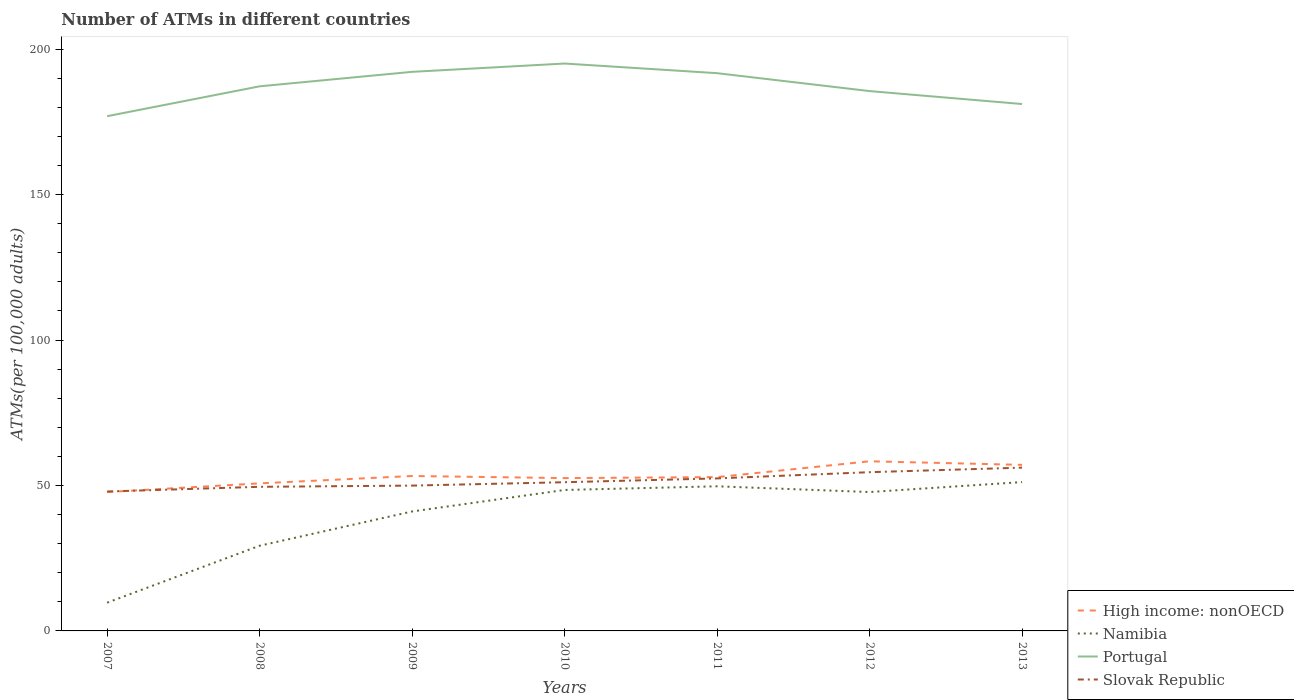How many different coloured lines are there?
Provide a succinct answer. 4. Does the line corresponding to Namibia intersect with the line corresponding to Portugal?
Your answer should be compact. No. Is the number of lines equal to the number of legend labels?
Your answer should be compact. Yes. Across all years, what is the maximum number of ATMs in Slovak Republic?
Give a very brief answer. 47.92. In which year was the number of ATMs in Namibia maximum?
Give a very brief answer. 2007. What is the total number of ATMs in Slovak Republic in the graph?
Offer a terse response. -2.89. What is the difference between the highest and the second highest number of ATMs in Namibia?
Offer a terse response. 41.45. How many years are there in the graph?
Give a very brief answer. 7. Does the graph contain grids?
Give a very brief answer. No. How are the legend labels stacked?
Provide a short and direct response. Vertical. What is the title of the graph?
Your response must be concise. Number of ATMs in different countries. Does "Ukraine" appear as one of the legend labels in the graph?
Give a very brief answer. No. What is the label or title of the X-axis?
Make the answer very short. Years. What is the label or title of the Y-axis?
Your answer should be very brief. ATMs(per 100,0 adults). What is the ATMs(per 100,000 adults) in High income: nonOECD in 2007?
Your answer should be compact. 47.74. What is the ATMs(per 100,000 adults) in Namibia in 2007?
Keep it short and to the point. 9.71. What is the ATMs(per 100,000 adults) of Portugal in 2007?
Your answer should be very brief. 176.94. What is the ATMs(per 100,000 adults) in Slovak Republic in 2007?
Provide a succinct answer. 47.92. What is the ATMs(per 100,000 adults) of High income: nonOECD in 2008?
Give a very brief answer. 50.72. What is the ATMs(per 100,000 adults) in Namibia in 2008?
Your response must be concise. 29.28. What is the ATMs(per 100,000 adults) in Portugal in 2008?
Offer a terse response. 187.21. What is the ATMs(per 100,000 adults) of Slovak Republic in 2008?
Your answer should be very brief. 49.54. What is the ATMs(per 100,000 adults) of High income: nonOECD in 2009?
Give a very brief answer. 53.26. What is the ATMs(per 100,000 adults) in Namibia in 2009?
Provide a succinct answer. 41.06. What is the ATMs(per 100,000 adults) in Portugal in 2009?
Make the answer very short. 192.19. What is the ATMs(per 100,000 adults) in Slovak Republic in 2009?
Offer a terse response. 49.96. What is the ATMs(per 100,000 adults) of High income: nonOECD in 2010?
Provide a succinct answer. 52.53. What is the ATMs(per 100,000 adults) of Namibia in 2010?
Provide a short and direct response. 48.46. What is the ATMs(per 100,000 adults) in Portugal in 2010?
Your response must be concise. 195.04. What is the ATMs(per 100,000 adults) of Slovak Republic in 2010?
Provide a short and direct response. 51.12. What is the ATMs(per 100,000 adults) in High income: nonOECD in 2011?
Your answer should be compact. 52.87. What is the ATMs(per 100,000 adults) of Namibia in 2011?
Keep it short and to the point. 49.72. What is the ATMs(per 100,000 adults) in Portugal in 2011?
Keep it short and to the point. 191.73. What is the ATMs(per 100,000 adults) in Slovak Republic in 2011?
Give a very brief answer. 52.43. What is the ATMs(per 100,000 adults) of High income: nonOECD in 2012?
Give a very brief answer. 58.31. What is the ATMs(per 100,000 adults) of Namibia in 2012?
Give a very brief answer. 47.74. What is the ATMs(per 100,000 adults) in Portugal in 2012?
Give a very brief answer. 185.57. What is the ATMs(per 100,000 adults) of Slovak Republic in 2012?
Ensure brevity in your answer.  54.57. What is the ATMs(per 100,000 adults) in High income: nonOECD in 2013?
Provide a short and direct response. 57.08. What is the ATMs(per 100,000 adults) of Namibia in 2013?
Offer a terse response. 51.16. What is the ATMs(per 100,000 adults) in Portugal in 2013?
Provide a succinct answer. 181.12. What is the ATMs(per 100,000 adults) in Slovak Republic in 2013?
Ensure brevity in your answer.  56.13. Across all years, what is the maximum ATMs(per 100,000 adults) of High income: nonOECD?
Offer a very short reply. 58.31. Across all years, what is the maximum ATMs(per 100,000 adults) of Namibia?
Offer a very short reply. 51.16. Across all years, what is the maximum ATMs(per 100,000 adults) in Portugal?
Ensure brevity in your answer.  195.04. Across all years, what is the maximum ATMs(per 100,000 adults) in Slovak Republic?
Make the answer very short. 56.13. Across all years, what is the minimum ATMs(per 100,000 adults) of High income: nonOECD?
Offer a very short reply. 47.74. Across all years, what is the minimum ATMs(per 100,000 adults) in Namibia?
Ensure brevity in your answer.  9.71. Across all years, what is the minimum ATMs(per 100,000 adults) of Portugal?
Give a very brief answer. 176.94. Across all years, what is the minimum ATMs(per 100,000 adults) of Slovak Republic?
Keep it short and to the point. 47.92. What is the total ATMs(per 100,000 adults) of High income: nonOECD in the graph?
Your answer should be very brief. 372.52. What is the total ATMs(per 100,000 adults) in Namibia in the graph?
Your response must be concise. 277.13. What is the total ATMs(per 100,000 adults) in Portugal in the graph?
Your answer should be compact. 1309.81. What is the total ATMs(per 100,000 adults) of Slovak Republic in the graph?
Keep it short and to the point. 361.66. What is the difference between the ATMs(per 100,000 adults) of High income: nonOECD in 2007 and that in 2008?
Offer a terse response. -2.98. What is the difference between the ATMs(per 100,000 adults) of Namibia in 2007 and that in 2008?
Give a very brief answer. -19.57. What is the difference between the ATMs(per 100,000 adults) in Portugal in 2007 and that in 2008?
Your response must be concise. -10.27. What is the difference between the ATMs(per 100,000 adults) in Slovak Republic in 2007 and that in 2008?
Your answer should be compact. -1.62. What is the difference between the ATMs(per 100,000 adults) in High income: nonOECD in 2007 and that in 2009?
Keep it short and to the point. -5.52. What is the difference between the ATMs(per 100,000 adults) in Namibia in 2007 and that in 2009?
Offer a terse response. -31.35. What is the difference between the ATMs(per 100,000 adults) of Portugal in 2007 and that in 2009?
Make the answer very short. -15.24. What is the difference between the ATMs(per 100,000 adults) of Slovak Republic in 2007 and that in 2009?
Ensure brevity in your answer.  -2.04. What is the difference between the ATMs(per 100,000 adults) of High income: nonOECD in 2007 and that in 2010?
Your response must be concise. -4.8. What is the difference between the ATMs(per 100,000 adults) of Namibia in 2007 and that in 2010?
Your answer should be compact. -38.74. What is the difference between the ATMs(per 100,000 adults) in Portugal in 2007 and that in 2010?
Make the answer very short. -18.1. What is the difference between the ATMs(per 100,000 adults) of Slovak Republic in 2007 and that in 2010?
Offer a terse response. -3.19. What is the difference between the ATMs(per 100,000 adults) in High income: nonOECD in 2007 and that in 2011?
Give a very brief answer. -5.14. What is the difference between the ATMs(per 100,000 adults) in Namibia in 2007 and that in 2011?
Offer a terse response. -40. What is the difference between the ATMs(per 100,000 adults) of Portugal in 2007 and that in 2011?
Offer a terse response. -14.79. What is the difference between the ATMs(per 100,000 adults) in Slovak Republic in 2007 and that in 2011?
Make the answer very short. -4.51. What is the difference between the ATMs(per 100,000 adults) of High income: nonOECD in 2007 and that in 2012?
Your response must be concise. -10.57. What is the difference between the ATMs(per 100,000 adults) in Namibia in 2007 and that in 2012?
Your response must be concise. -38.03. What is the difference between the ATMs(per 100,000 adults) of Portugal in 2007 and that in 2012?
Your answer should be compact. -8.63. What is the difference between the ATMs(per 100,000 adults) in Slovak Republic in 2007 and that in 2012?
Offer a terse response. -6.64. What is the difference between the ATMs(per 100,000 adults) in High income: nonOECD in 2007 and that in 2013?
Ensure brevity in your answer.  -9.34. What is the difference between the ATMs(per 100,000 adults) in Namibia in 2007 and that in 2013?
Give a very brief answer. -41.45. What is the difference between the ATMs(per 100,000 adults) of Portugal in 2007 and that in 2013?
Make the answer very short. -4.18. What is the difference between the ATMs(per 100,000 adults) in Slovak Republic in 2007 and that in 2013?
Provide a short and direct response. -8.21. What is the difference between the ATMs(per 100,000 adults) of High income: nonOECD in 2008 and that in 2009?
Your answer should be very brief. -2.53. What is the difference between the ATMs(per 100,000 adults) of Namibia in 2008 and that in 2009?
Keep it short and to the point. -11.78. What is the difference between the ATMs(per 100,000 adults) of Portugal in 2008 and that in 2009?
Offer a very short reply. -4.98. What is the difference between the ATMs(per 100,000 adults) in Slovak Republic in 2008 and that in 2009?
Your answer should be compact. -0.42. What is the difference between the ATMs(per 100,000 adults) in High income: nonOECD in 2008 and that in 2010?
Give a very brief answer. -1.81. What is the difference between the ATMs(per 100,000 adults) in Namibia in 2008 and that in 2010?
Your answer should be compact. -19.17. What is the difference between the ATMs(per 100,000 adults) of Portugal in 2008 and that in 2010?
Ensure brevity in your answer.  -7.83. What is the difference between the ATMs(per 100,000 adults) of Slovak Republic in 2008 and that in 2010?
Provide a succinct answer. -1.58. What is the difference between the ATMs(per 100,000 adults) of High income: nonOECD in 2008 and that in 2011?
Keep it short and to the point. -2.15. What is the difference between the ATMs(per 100,000 adults) in Namibia in 2008 and that in 2011?
Keep it short and to the point. -20.43. What is the difference between the ATMs(per 100,000 adults) in Portugal in 2008 and that in 2011?
Ensure brevity in your answer.  -4.52. What is the difference between the ATMs(per 100,000 adults) of Slovak Republic in 2008 and that in 2011?
Provide a succinct answer. -2.89. What is the difference between the ATMs(per 100,000 adults) of High income: nonOECD in 2008 and that in 2012?
Your answer should be very brief. -7.59. What is the difference between the ATMs(per 100,000 adults) of Namibia in 2008 and that in 2012?
Offer a terse response. -18.46. What is the difference between the ATMs(per 100,000 adults) in Portugal in 2008 and that in 2012?
Provide a short and direct response. 1.64. What is the difference between the ATMs(per 100,000 adults) of Slovak Republic in 2008 and that in 2012?
Make the answer very short. -5.03. What is the difference between the ATMs(per 100,000 adults) of High income: nonOECD in 2008 and that in 2013?
Your answer should be very brief. -6.36. What is the difference between the ATMs(per 100,000 adults) in Namibia in 2008 and that in 2013?
Keep it short and to the point. -21.88. What is the difference between the ATMs(per 100,000 adults) in Portugal in 2008 and that in 2013?
Offer a very short reply. 6.09. What is the difference between the ATMs(per 100,000 adults) of Slovak Republic in 2008 and that in 2013?
Offer a very short reply. -6.59. What is the difference between the ATMs(per 100,000 adults) of High income: nonOECD in 2009 and that in 2010?
Offer a very short reply. 0.72. What is the difference between the ATMs(per 100,000 adults) in Namibia in 2009 and that in 2010?
Keep it short and to the point. -7.39. What is the difference between the ATMs(per 100,000 adults) in Portugal in 2009 and that in 2010?
Offer a terse response. -2.86. What is the difference between the ATMs(per 100,000 adults) of Slovak Republic in 2009 and that in 2010?
Your response must be concise. -1.16. What is the difference between the ATMs(per 100,000 adults) in High income: nonOECD in 2009 and that in 2011?
Provide a succinct answer. 0.38. What is the difference between the ATMs(per 100,000 adults) in Namibia in 2009 and that in 2011?
Give a very brief answer. -8.65. What is the difference between the ATMs(per 100,000 adults) in Portugal in 2009 and that in 2011?
Make the answer very short. 0.46. What is the difference between the ATMs(per 100,000 adults) in Slovak Republic in 2009 and that in 2011?
Ensure brevity in your answer.  -2.47. What is the difference between the ATMs(per 100,000 adults) of High income: nonOECD in 2009 and that in 2012?
Offer a very short reply. -5.05. What is the difference between the ATMs(per 100,000 adults) in Namibia in 2009 and that in 2012?
Keep it short and to the point. -6.68. What is the difference between the ATMs(per 100,000 adults) of Portugal in 2009 and that in 2012?
Your response must be concise. 6.62. What is the difference between the ATMs(per 100,000 adults) of Slovak Republic in 2009 and that in 2012?
Provide a succinct answer. -4.61. What is the difference between the ATMs(per 100,000 adults) in High income: nonOECD in 2009 and that in 2013?
Offer a very short reply. -3.83. What is the difference between the ATMs(per 100,000 adults) of Namibia in 2009 and that in 2013?
Provide a succinct answer. -10.1. What is the difference between the ATMs(per 100,000 adults) in Portugal in 2009 and that in 2013?
Provide a succinct answer. 11.06. What is the difference between the ATMs(per 100,000 adults) of Slovak Republic in 2009 and that in 2013?
Offer a very short reply. -6.17. What is the difference between the ATMs(per 100,000 adults) of High income: nonOECD in 2010 and that in 2011?
Your answer should be compact. -0.34. What is the difference between the ATMs(per 100,000 adults) in Namibia in 2010 and that in 2011?
Offer a very short reply. -1.26. What is the difference between the ATMs(per 100,000 adults) in Portugal in 2010 and that in 2011?
Give a very brief answer. 3.31. What is the difference between the ATMs(per 100,000 adults) in Slovak Republic in 2010 and that in 2011?
Your answer should be compact. -1.31. What is the difference between the ATMs(per 100,000 adults) in High income: nonOECD in 2010 and that in 2012?
Your answer should be compact. -5.78. What is the difference between the ATMs(per 100,000 adults) of Namibia in 2010 and that in 2012?
Ensure brevity in your answer.  0.72. What is the difference between the ATMs(per 100,000 adults) in Portugal in 2010 and that in 2012?
Offer a terse response. 9.47. What is the difference between the ATMs(per 100,000 adults) of Slovak Republic in 2010 and that in 2012?
Your response must be concise. -3.45. What is the difference between the ATMs(per 100,000 adults) of High income: nonOECD in 2010 and that in 2013?
Give a very brief answer. -4.55. What is the difference between the ATMs(per 100,000 adults) of Namibia in 2010 and that in 2013?
Your answer should be compact. -2.7. What is the difference between the ATMs(per 100,000 adults) in Portugal in 2010 and that in 2013?
Provide a short and direct response. 13.92. What is the difference between the ATMs(per 100,000 adults) in Slovak Republic in 2010 and that in 2013?
Provide a short and direct response. -5.01. What is the difference between the ATMs(per 100,000 adults) in High income: nonOECD in 2011 and that in 2012?
Keep it short and to the point. -5.44. What is the difference between the ATMs(per 100,000 adults) in Namibia in 2011 and that in 2012?
Your answer should be very brief. 1.97. What is the difference between the ATMs(per 100,000 adults) of Portugal in 2011 and that in 2012?
Offer a terse response. 6.16. What is the difference between the ATMs(per 100,000 adults) of Slovak Republic in 2011 and that in 2012?
Give a very brief answer. -2.14. What is the difference between the ATMs(per 100,000 adults) in High income: nonOECD in 2011 and that in 2013?
Provide a short and direct response. -4.21. What is the difference between the ATMs(per 100,000 adults) in Namibia in 2011 and that in 2013?
Your answer should be compact. -1.44. What is the difference between the ATMs(per 100,000 adults) in Portugal in 2011 and that in 2013?
Offer a very short reply. 10.6. What is the difference between the ATMs(per 100,000 adults) of Slovak Republic in 2011 and that in 2013?
Offer a very short reply. -3.7. What is the difference between the ATMs(per 100,000 adults) of High income: nonOECD in 2012 and that in 2013?
Your answer should be very brief. 1.23. What is the difference between the ATMs(per 100,000 adults) in Namibia in 2012 and that in 2013?
Give a very brief answer. -3.42. What is the difference between the ATMs(per 100,000 adults) in Portugal in 2012 and that in 2013?
Offer a very short reply. 4.45. What is the difference between the ATMs(per 100,000 adults) in Slovak Republic in 2012 and that in 2013?
Give a very brief answer. -1.56. What is the difference between the ATMs(per 100,000 adults) of High income: nonOECD in 2007 and the ATMs(per 100,000 adults) of Namibia in 2008?
Keep it short and to the point. 18.46. What is the difference between the ATMs(per 100,000 adults) of High income: nonOECD in 2007 and the ATMs(per 100,000 adults) of Portugal in 2008?
Give a very brief answer. -139.47. What is the difference between the ATMs(per 100,000 adults) in High income: nonOECD in 2007 and the ATMs(per 100,000 adults) in Slovak Republic in 2008?
Provide a succinct answer. -1.8. What is the difference between the ATMs(per 100,000 adults) in Namibia in 2007 and the ATMs(per 100,000 adults) in Portugal in 2008?
Offer a terse response. -177.5. What is the difference between the ATMs(per 100,000 adults) in Namibia in 2007 and the ATMs(per 100,000 adults) in Slovak Republic in 2008?
Offer a very short reply. -39.83. What is the difference between the ATMs(per 100,000 adults) in Portugal in 2007 and the ATMs(per 100,000 adults) in Slovak Republic in 2008?
Make the answer very short. 127.4. What is the difference between the ATMs(per 100,000 adults) in High income: nonOECD in 2007 and the ATMs(per 100,000 adults) in Namibia in 2009?
Your answer should be compact. 6.68. What is the difference between the ATMs(per 100,000 adults) of High income: nonOECD in 2007 and the ATMs(per 100,000 adults) of Portugal in 2009?
Offer a very short reply. -144.45. What is the difference between the ATMs(per 100,000 adults) of High income: nonOECD in 2007 and the ATMs(per 100,000 adults) of Slovak Republic in 2009?
Your answer should be compact. -2.22. What is the difference between the ATMs(per 100,000 adults) of Namibia in 2007 and the ATMs(per 100,000 adults) of Portugal in 2009?
Provide a succinct answer. -182.48. What is the difference between the ATMs(per 100,000 adults) of Namibia in 2007 and the ATMs(per 100,000 adults) of Slovak Republic in 2009?
Ensure brevity in your answer.  -40.25. What is the difference between the ATMs(per 100,000 adults) in Portugal in 2007 and the ATMs(per 100,000 adults) in Slovak Republic in 2009?
Your answer should be compact. 126.99. What is the difference between the ATMs(per 100,000 adults) in High income: nonOECD in 2007 and the ATMs(per 100,000 adults) in Namibia in 2010?
Offer a terse response. -0.72. What is the difference between the ATMs(per 100,000 adults) in High income: nonOECD in 2007 and the ATMs(per 100,000 adults) in Portugal in 2010?
Keep it short and to the point. -147.3. What is the difference between the ATMs(per 100,000 adults) of High income: nonOECD in 2007 and the ATMs(per 100,000 adults) of Slovak Republic in 2010?
Offer a terse response. -3.38. What is the difference between the ATMs(per 100,000 adults) of Namibia in 2007 and the ATMs(per 100,000 adults) of Portugal in 2010?
Provide a short and direct response. -185.33. What is the difference between the ATMs(per 100,000 adults) of Namibia in 2007 and the ATMs(per 100,000 adults) of Slovak Republic in 2010?
Your answer should be very brief. -41.4. What is the difference between the ATMs(per 100,000 adults) of Portugal in 2007 and the ATMs(per 100,000 adults) of Slovak Republic in 2010?
Make the answer very short. 125.83. What is the difference between the ATMs(per 100,000 adults) in High income: nonOECD in 2007 and the ATMs(per 100,000 adults) in Namibia in 2011?
Give a very brief answer. -1.98. What is the difference between the ATMs(per 100,000 adults) of High income: nonOECD in 2007 and the ATMs(per 100,000 adults) of Portugal in 2011?
Make the answer very short. -143.99. What is the difference between the ATMs(per 100,000 adults) in High income: nonOECD in 2007 and the ATMs(per 100,000 adults) in Slovak Republic in 2011?
Ensure brevity in your answer.  -4.69. What is the difference between the ATMs(per 100,000 adults) of Namibia in 2007 and the ATMs(per 100,000 adults) of Portugal in 2011?
Your response must be concise. -182.02. What is the difference between the ATMs(per 100,000 adults) of Namibia in 2007 and the ATMs(per 100,000 adults) of Slovak Republic in 2011?
Offer a terse response. -42.72. What is the difference between the ATMs(per 100,000 adults) of Portugal in 2007 and the ATMs(per 100,000 adults) of Slovak Republic in 2011?
Your answer should be compact. 124.51. What is the difference between the ATMs(per 100,000 adults) in High income: nonOECD in 2007 and the ATMs(per 100,000 adults) in Namibia in 2012?
Offer a very short reply. -0. What is the difference between the ATMs(per 100,000 adults) of High income: nonOECD in 2007 and the ATMs(per 100,000 adults) of Portugal in 2012?
Provide a succinct answer. -137.83. What is the difference between the ATMs(per 100,000 adults) in High income: nonOECD in 2007 and the ATMs(per 100,000 adults) in Slovak Republic in 2012?
Offer a very short reply. -6.83. What is the difference between the ATMs(per 100,000 adults) in Namibia in 2007 and the ATMs(per 100,000 adults) in Portugal in 2012?
Your response must be concise. -175.86. What is the difference between the ATMs(per 100,000 adults) in Namibia in 2007 and the ATMs(per 100,000 adults) in Slovak Republic in 2012?
Your answer should be compact. -44.85. What is the difference between the ATMs(per 100,000 adults) in Portugal in 2007 and the ATMs(per 100,000 adults) in Slovak Republic in 2012?
Give a very brief answer. 122.38. What is the difference between the ATMs(per 100,000 adults) in High income: nonOECD in 2007 and the ATMs(per 100,000 adults) in Namibia in 2013?
Provide a succinct answer. -3.42. What is the difference between the ATMs(per 100,000 adults) of High income: nonOECD in 2007 and the ATMs(per 100,000 adults) of Portugal in 2013?
Offer a very short reply. -133.39. What is the difference between the ATMs(per 100,000 adults) of High income: nonOECD in 2007 and the ATMs(per 100,000 adults) of Slovak Republic in 2013?
Your answer should be compact. -8.39. What is the difference between the ATMs(per 100,000 adults) in Namibia in 2007 and the ATMs(per 100,000 adults) in Portugal in 2013?
Your answer should be compact. -171.41. What is the difference between the ATMs(per 100,000 adults) in Namibia in 2007 and the ATMs(per 100,000 adults) in Slovak Republic in 2013?
Make the answer very short. -46.42. What is the difference between the ATMs(per 100,000 adults) of Portugal in 2007 and the ATMs(per 100,000 adults) of Slovak Republic in 2013?
Make the answer very short. 120.81. What is the difference between the ATMs(per 100,000 adults) in High income: nonOECD in 2008 and the ATMs(per 100,000 adults) in Namibia in 2009?
Offer a very short reply. 9.66. What is the difference between the ATMs(per 100,000 adults) in High income: nonOECD in 2008 and the ATMs(per 100,000 adults) in Portugal in 2009?
Ensure brevity in your answer.  -141.47. What is the difference between the ATMs(per 100,000 adults) in High income: nonOECD in 2008 and the ATMs(per 100,000 adults) in Slovak Republic in 2009?
Your response must be concise. 0.76. What is the difference between the ATMs(per 100,000 adults) of Namibia in 2008 and the ATMs(per 100,000 adults) of Portugal in 2009?
Ensure brevity in your answer.  -162.9. What is the difference between the ATMs(per 100,000 adults) in Namibia in 2008 and the ATMs(per 100,000 adults) in Slovak Republic in 2009?
Your response must be concise. -20.67. What is the difference between the ATMs(per 100,000 adults) of Portugal in 2008 and the ATMs(per 100,000 adults) of Slovak Republic in 2009?
Provide a short and direct response. 137.25. What is the difference between the ATMs(per 100,000 adults) of High income: nonOECD in 2008 and the ATMs(per 100,000 adults) of Namibia in 2010?
Keep it short and to the point. 2.27. What is the difference between the ATMs(per 100,000 adults) of High income: nonOECD in 2008 and the ATMs(per 100,000 adults) of Portugal in 2010?
Provide a short and direct response. -144.32. What is the difference between the ATMs(per 100,000 adults) of High income: nonOECD in 2008 and the ATMs(per 100,000 adults) of Slovak Republic in 2010?
Your answer should be very brief. -0.39. What is the difference between the ATMs(per 100,000 adults) of Namibia in 2008 and the ATMs(per 100,000 adults) of Portugal in 2010?
Offer a very short reply. -165.76. What is the difference between the ATMs(per 100,000 adults) of Namibia in 2008 and the ATMs(per 100,000 adults) of Slovak Republic in 2010?
Your answer should be compact. -21.83. What is the difference between the ATMs(per 100,000 adults) of Portugal in 2008 and the ATMs(per 100,000 adults) of Slovak Republic in 2010?
Give a very brief answer. 136.09. What is the difference between the ATMs(per 100,000 adults) of High income: nonOECD in 2008 and the ATMs(per 100,000 adults) of Portugal in 2011?
Your answer should be compact. -141.01. What is the difference between the ATMs(per 100,000 adults) in High income: nonOECD in 2008 and the ATMs(per 100,000 adults) in Slovak Republic in 2011?
Offer a terse response. -1.71. What is the difference between the ATMs(per 100,000 adults) in Namibia in 2008 and the ATMs(per 100,000 adults) in Portugal in 2011?
Keep it short and to the point. -162.45. What is the difference between the ATMs(per 100,000 adults) of Namibia in 2008 and the ATMs(per 100,000 adults) of Slovak Republic in 2011?
Keep it short and to the point. -23.15. What is the difference between the ATMs(per 100,000 adults) in Portugal in 2008 and the ATMs(per 100,000 adults) in Slovak Republic in 2011?
Your answer should be very brief. 134.78. What is the difference between the ATMs(per 100,000 adults) of High income: nonOECD in 2008 and the ATMs(per 100,000 adults) of Namibia in 2012?
Provide a succinct answer. 2.98. What is the difference between the ATMs(per 100,000 adults) in High income: nonOECD in 2008 and the ATMs(per 100,000 adults) in Portugal in 2012?
Your response must be concise. -134.85. What is the difference between the ATMs(per 100,000 adults) in High income: nonOECD in 2008 and the ATMs(per 100,000 adults) in Slovak Republic in 2012?
Offer a very short reply. -3.84. What is the difference between the ATMs(per 100,000 adults) in Namibia in 2008 and the ATMs(per 100,000 adults) in Portugal in 2012?
Offer a terse response. -156.29. What is the difference between the ATMs(per 100,000 adults) of Namibia in 2008 and the ATMs(per 100,000 adults) of Slovak Republic in 2012?
Make the answer very short. -25.28. What is the difference between the ATMs(per 100,000 adults) of Portugal in 2008 and the ATMs(per 100,000 adults) of Slovak Republic in 2012?
Give a very brief answer. 132.64. What is the difference between the ATMs(per 100,000 adults) in High income: nonOECD in 2008 and the ATMs(per 100,000 adults) in Namibia in 2013?
Give a very brief answer. -0.44. What is the difference between the ATMs(per 100,000 adults) in High income: nonOECD in 2008 and the ATMs(per 100,000 adults) in Portugal in 2013?
Your answer should be compact. -130.4. What is the difference between the ATMs(per 100,000 adults) of High income: nonOECD in 2008 and the ATMs(per 100,000 adults) of Slovak Republic in 2013?
Make the answer very short. -5.41. What is the difference between the ATMs(per 100,000 adults) in Namibia in 2008 and the ATMs(per 100,000 adults) in Portugal in 2013?
Your answer should be compact. -151.84. What is the difference between the ATMs(per 100,000 adults) in Namibia in 2008 and the ATMs(per 100,000 adults) in Slovak Republic in 2013?
Give a very brief answer. -26.84. What is the difference between the ATMs(per 100,000 adults) in Portugal in 2008 and the ATMs(per 100,000 adults) in Slovak Republic in 2013?
Offer a very short reply. 131.08. What is the difference between the ATMs(per 100,000 adults) in High income: nonOECD in 2009 and the ATMs(per 100,000 adults) in Namibia in 2010?
Provide a short and direct response. 4.8. What is the difference between the ATMs(per 100,000 adults) of High income: nonOECD in 2009 and the ATMs(per 100,000 adults) of Portugal in 2010?
Your answer should be compact. -141.79. What is the difference between the ATMs(per 100,000 adults) in High income: nonOECD in 2009 and the ATMs(per 100,000 adults) in Slovak Republic in 2010?
Ensure brevity in your answer.  2.14. What is the difference between the ATMs(per 100,000 adults) of Namibia in 2009 and the ATMs(per 100,000 adults) of Portugal in 2010?
Make the answer very short. -153.98. What is the difference between the ATMs(per 100,000 adults) in Namibia in 2009 and the ATMs(per 100,000 adults) in Slovak Republic in 2010?
Keep it short and to the point. -10.05. What is the difference between the ATMs(per 100,000 adults) in Portugal in 2009 and the ATMs(per 100,000 adults) in Slovak Republic in 2010?
Your answer should be very brief. 141.07. What is the difference between the ATMs(per 100,000 adults) in High income: nonOECD in 2009 and the ATMs(per 100,000 adults) in Namibia in 2011?
Provide a short and direct response. 3.54. What is the difference between the ATMs(per 100,000 adults) in High income: nonOECD in 2009 and the ATMs(per 100,000 adults) in Portugal in 2011?
Offer a very short reply. -138.47. What is the difference between the ATMs(per 100,000 adults) in High income: nonOECD in 2009 and the ATMs(per 100,000 adults) in Slovak Republic in 2011?
Provide a short and direct response. 0.83. What is the difference between the ATMs(per 100,000 adults) of Namibia in 2009 and the ATMs(per 100,000 adults) of Portugal in 2011?
Offer a terse response. -150.67. What is the difference between the ATMs(per 100,000 adults) of Namibia in 2009 and the ATMs(per 100,000 adults) of Slovak Republic in 2011?
Offer a terse response. -11.37. What is the difference between the ATMs(per 100,000 adults) in Portugal in 2009 and the ATMs(per 100,000 adults) in Slovak Republic in 2011?
Offer a very short reply. 139.76. What is the difference between the ATMs(per 100,000 adults) in High income: nonOECD in 2009 and the ATMs(per 100,000 adults) in Namibia in 2012?
Offer a very short reply. 5.52. What is the difference between the ATMs(per 100,000 adults) of High income: nonOECD in 2009 and the ATMs(per 100,000 adults) of Portugal in 2012?
Give a very brief answer. -132.31. What is the difference between the ATMs(per 100,000 adults) in High income: nonOECD in 2009 and the ATMs(per 100,000 adults) in Slovak Republic in 2012?
Offer a terse response. -1.31. What is the difference between the ATMs(per 100,000 adults) of Namibia in 2009 and the ATMs(per 100,000 adults) of Portugal in 2012?
Offer a terse response. -144.51. What is the difference between the ATMs(per 100,000 adults) in Namibia in 2009 and the ATMs(per 100,000 adults) in Slovak Republic in 2012?
Give a very brief answer. -13.5. What is the difference between the ATMs(per 100,000 adults) in Portugal in 2009 and the ATMs(per 100,000 adults) in Slovak Republic in 2012?
Offer a terse response. 137.62. What is the difference between the ATMs(per 100,000 adults) of High income: nonOECD in 2009 and the ATMs(per 100,000 adults) of Namibia in 2013?
Your answer should be compact. 2.1. What is the difference between the ATMs(per 100,000 adults) of High income: nonOECD in 2009 and the ATMs(per 100,000 adults) of Portugal in 2013?
Your answer should be very brief. -127.87. What is the difference between the ATMs(per 100,000 adults) in High income: nonOECD in 2009 and the ATMs(per 100,000 adults) in Slovak Republic in 2013?
Provide a succinct answer. -2.87. What is the difference between the ATMs(per 100,000 adults) in Namibia in 2009 and the ATMs(per 100,000 adults) in Portugal in 2013?
Your response must be concise. -140.06. What is the difference between the ATMs(per 100,000 adults) of Namibia in 2009 and the ATMs(per 100,000 adults) of Slovak Republic in 2013?
Ensure brevity in your answer.  -15.06. What is the difference between the ATMs(per 100,000 adults) of Portugal in 2009 and the ATMs(per 100,000 adults) of Slovak Republic in 2013?
Offer a very short reply. 136.06. What is the difference between the ATMs(per 100,000 adults) of High income: nonOECD in 2010 and the ATMs(per 100,000 adults) of Namibia in 2011?
Make the answer very short. 2.82. What is the difference between the ATMs(per 100,000 adults) of High income: nonOECD in 2010 and the ATMs(per 100,000 adults) of Portugal in 2011?
Keep it short and to the point. -139.19. What is the difference between the ATMs(per 100,000 adults) of High income: nonOECD in 2010 and the ATMs(per 100,000 adults) of Slovak Republic in 2011?
Provide a short and direct response. 0.11. What is the difference between the ATMs(per 100,000 adults) in Namibia in 2010 and the ATMs(per 100,000 adults) in Portugal in 2011?
Offer a terse response. -143.27. What is the difference between the ATMs(per 100,000 adults) in Namibia in 2010 and the ATMs(per 100,000 adults) in Slovak Republic in 2011?
Your answer should be compact. -3.97. What is the difference between the ATMs(per 100,000 adults) in Portugal in 2010 and the ATMs(per 100,000 adults) in Slovak Republic in 2011?
Provide a short and direct response. 142.61. What is the difference between the ATMs(per 100,000 adults) in High income: nonOECD in 2010 and the ATMs(per 100,000 adults) in Namibia in 2012?
Your answer should be compact. 4.79. What is the difference between the ATMs(per 100,000 adults) in High income: nonOECD in 2010 and the ATMs(per 100,000 adults) in Portugal in 2012?
Make the answer very short. -133.04. What is the difference between the ATMs(per 100,000 adults) in High income: nonOECD in 2010 and the ATMs(per 100,000 adults) in Slovak Republic in 2012?
Give a very brief answer. -2.03. What is the difference between the ATMs(per 100,000 adults) of Namibia in 2010 and the ATMs(per 100,000 adults) of Portugal in 2012?
Provide a short and direct response. -137.11. What is the difference between the ATMs(per 100,000 adults) of Namibia in 2010 and the ATMs(per 100,000 adults) of Slovak Republic in 2012?
Offer a very short reply. -6.11. What is the difference between the ATMs(per 100,000 adults) of Portugal in 2010 and the ATMs(per 100,000 adults) of Slovak Republic in 2012?
Offer a very short reply. 140.48. What is the difference between the ATMs(per 100,000 adults) of High income: nonOECD in 2010 and the ATMs(per 100,000 adults) of Namibia in 2013?
Give a very brief answer. 1.37. What is the difference between the ATMs(per 100,000 adults) in High income: nonOECD in 2010 and the ATMs(per 100,000 adults) in Portugal in 2013?
Offer a terse response. -128.59. What is the difference between the ATMs(per 100,000 adults) in High income: nonOECD in 2010 and the ATMs(per 100,000 adults) in Slovak Republic in 2013?
Give a very brief answer. -3.59. What is the difference between the ATMs(per 100,000 adults) of Namibia in 2010 and the ATMs(per 100,000 adults) of Portugal in 2013?
Make the answer very short. -132.67. What is the difference between the ATMs(per 100,000 adults) of Namibia in 2010 and the ATMs(per 100,000 adults) of Slovak Republic in 2013?
Provide a succinct answer. -7.67. What is the difference between the ATMs(per 100,000 adults) of Portugal in 2010 and the ATMs(per 100,000 adults) of Slovak Republic in 2013?
Your answer should be very brief. 138.92. What is the difference between the ATMs(per 100,000 adults) in High income: nonOECD in 2011 and the ATMs(per 100,000 adults) in Namibia in 2012?
Keep it short and to the point. 5.13. What is the difference between the ATMs(per 100,000 adults) of High income: nonOECD in 2011 and the ATMs(per 100,000 adults) of Portugal in 2012?
Keep it short and to the point. -132.7. What is the difference between the ATMs(per 100,000 adults) in High income: nonOECD in 2011 and the ATMs(per 100,000 adults) in Slovak Republic in 2012?
Offer a very short reply. -1.69. What is the difference between the ATMs(per 100,000 adults) of Namibia in 2011 and the ATMs(per 100,000 adults) of Portugal in 2012?
Provide a short and direct response. -135.86. What is the difference between the ATMs(per 100,000 adults) of Namibia in 2011 and the ATMs(per 100,000 adults) of Slovak Republic in 2012?
Provide a succinct answer. -4.85. What is the difference between the ATMs(per 100,000 adults) in Portugal in 2011 and the ATMs(per 100,000 adults) in Slovak Republic in 2012?
Your answer should be very brief. 137.16. What is the difference between the ATMs(per 100,000 adults) in High income: nonOECD in 2011 and the ATMs(per 100,000 adults) in Namibia in 2013?
Ensure brevity in your answer.  1.71. What is the difference between the ATMs(per 100,000 adults) of High income: nonOECD in 2011 and the ATMs(per 100,000 adults) of Portugal in 2013?
Provide a short and direct response. -128.25. What is the difference between the ATMs(per 100,000 adults) of High income: nonOECD in 2011 and the ATMs(per 100,000 adults) of Slovak Republic in 2013?
Ensure brevity in your answer.  -3.25. What is the difference between the ATMs(per 100,000 adults) of Namibia in 2011 and the ATMs(per 100,000 adults) of Portugal in 2013?
Your answer should be compact. -131.41. What is the difference between the ATMs(per 100,000 adults) of Namibia in 2011 and the ATMs(per 100,000 adults) of Slovak Republic in 2013?
Provide a short and direct response. -6.41. What is the difference between the ATMs(per 100,000 adults) in Portugal in 2011 and the ATMs(per 100,000 adults) in Slovak Republic in 2013?
Offer a very short reply. 135.6. What is the difference between the ATMs(per 100,000 adults) of High income: nonOECD in 2012 and the ATMs(per 100,000 adults) of Namibia in 2013?
Ensure brevity in your answer.  7.15. What is the difference between the ATMs(per 100,000 adults) of High income: nonOECD in 2012 and the ATMs(per 100,000 adults) of Portugal in 2013?
Provide a short and direct response. -122.81. What is the difference between the ATMs(per 100,000 adults) of High income: nonOECD in 2012 and the ATMs(per 100,000 adults) of Slovak Republic in 2013?
Offer a very short reply. 2.18. What is the difference between the ATMs(per 100,000 adults) of Namibia in 2012 and the ATMs(per 100,000 adults) of Portugal in 2013?
Provide a succinct answer. -133.38. What is the difference between the ATMs(per 100,000 adults) of Namibia in 2012 and the ATMs(per 100,000 adults) of Slovak Republic in 2013?
Ensure brevity in your answer.  -8.39. What is the difference between the ATMs(per 100,000 adults) in Portugal in 2012 and the ATMs(per 100,000 adults) in Slovak Republic in 2013?
Keep it short and to the point. 129.44. What is the average ATMs(per 100,000 adults) in High income: nonOECD per year?
Offer a terse response. 53.22. What is the average ATMs(per 100,000 adults) in Namibia per year?
Provide a succinct answer. 39.59. What is the average ATMs(per 100,000 adults) in Portugal per year?
Offer a terse response. 187.12. What is the average ATMs(per 100,000 adults) of Slovak Republic per year?
Provide a short and direct response. 51.67. In the year 2007, what is the difference between the ATMs(per 100,000 adults) in High income: nonOECD and ATMs(per 100,000 adults) in Namibia?
Your response must be concise. 38.03. In the year 2007, what is the difference between the ATMs(per 100,000 adults) of High income: nonOECD and ATMs(per 100,000 adults) of Portugal?
Provide a succinct answer. -129.2. In the year 2007, what is the difference between the ATMs(per 100,000 adults) of High income: nonOECD and ATMs(per 100,000 adults) of Slovak Republic?
Offer a terse response. -0.18. In the year 2007, what is the difference between the ATMs(per 100,000 adults) of Namibia and ATMs(per 100,000 adults) of Portugal?
Keep it short and to the point. -167.23. In the year 2007, what is the difference between the ATMs(per 100,000 adults) of Namibia and ATMs(per 100,000 adults) of Slovak Republic?
Offer a terse response. -38.21. In the year 2007, what is the difference between the ATMs(per 100,000 adults) of Portugal and ATMs(per 100,000 adults) of Slovak Republic?
Keep it short and to the point. 129.02. In the year 2008, what is the difference between the ATMs(per 100,000 adults) of High income: nonOECD and ATMs(per 100,000 adults) of Namibia?
Make the answer very short. 21.44. In the year 2008, what is the difference between the ATMs(per 100,000 adults) in High income: nonOECD and ATMs(per 100,000 adults) in Portugal?
Give a very brief answer. -136.49. In the year 2008, what is the difference between the ATMs(per 100,000 adults) of High income: nonOECD and ATMs(per 100,000 adults) of Slovak Republic?
Your response must be concise. 1.18. In the year 2008, what is the difference between the ATMs(per 100,000 adults) of Namibia and ATMs(per 100,000 adults) of Portugal?
Your answer should be very brief. -157.93. In the year 2008, what is the difference between the ATMs(per 100,000 adults) in Namibia and ATMs(per 100,000 adults) in Slovak Republic?
Keep it short and to the point. -20.26. In the year 2008, what is the difference between the ATMs(per 100,000 adults) in Portugal and ATMs(per 100,000 adults) in Slovak Republic?
Ensure brevity in your answer.  137.67. In the year 2009, what is the difference between the ATMs(per 100,000 adults) of High income: nonOECD and ATMs(per 100,000 adults) of Namibia?
Your answer should be compact. 12.19. In the year 2009, what is the difference between the ATMs(per 100,000 adults) in High income: nonOECD and ATMs(per 100,000 adults) in Portugal?
Provide a short and direct response. -138.93. In the year 2009, what is the difference between the ATMs(per 100,000 adults) in High income: nonOECD and ATMs(per 100,000 adults) in Slovak Republic?
Your response must be concise. 3.3. In the year 2009, what is the difference between the ATMs(per 100,000 adults) in Namibia and ATMs(per 100,000 adults) in Portugal?
Your answer should be compact. -151.12. In the year 2009, what is the difference between the ATMs(per 100,000 adults) in Namibia and ATMs(per 100,000 adults) in Slovak Republic?
Your answer should be very brief. -8.89. In the year 2009, what is the difference between the ATMs(per 100,000 adults) in Portugal and ATMs(per 100,000 adults) in Slovak Republic?
Ensure brevity in your answer.  142.23. In the year 2010, what is the difference between the ATMs(per 100,000 adults) in High income: nonOECD and ATMs(per 100,000 adults) in Namibia?
Provide a short and direct response. 4.08. In the year 2010, what is the difference between the ATMs(per 100,000 adults) in High income: nonOECD and ATMs(per 100,000 adults) in Portugal?
Give a very brief answer. -142.51. In the year 2010, what is the difference between the ATMs(per 100,000 adults) of High income: nonOECD and ATMs(per 100,000 adults) of Slovak Republic?
Your answer should be very brief. 1.42. In the year 2010, what is the difference between the ATMs(per 100,000 adults) of Namibia and ATMs(per 100,000 adults) of Portugal?
Offer a terse response. -146.59. In the year 2010, what is the difference between the ATMs(per 100,000 adults) in Namibia and ATMs(per 100,000 adults) in Slovak Republic?
Offer a terse response. -2.66. In the year 2010, what is the difference between the ATMs(per 100,000 adults) in Portugal and ATMs(per 100,000 adults) in Slovak Republic?
Provide a short and direct response. 143.93. In the year 2011, what is the difference between the ATMs(per 100,000 adults) of High income: nonOECD and ATMs(per 100,000 adults) of Namibia?
Make the answer very short. 3.16. In the year 2011, what is the difference between the ATMs(per 100,000 adults) of High income: nonOECD and ATMs(per 100,000 adults) of Portugal?
Offer a terse response. -138.85. In the year 2011, what is the difference between the ATMs(per 100,000 adults) of High income: nonOECD and ATMs(per 100,000 adults) of Slovak Republic?
Your answer should be compact. 0.45. In the year 2011, what is the difference between the ATMs(per 100,000 adults) in Namibia and ATMs(per 100,000 adults) in Portugal?
Provide a succinct answer. -142.01. In the year 2011, what is the difference between the ATMs(per 100,000 adults) of Namibia and ATMs(per 100,000 adults) of Slovak Republic?
Keep it short and to the point. -2.71. In the year 2011, what is the difference between the ATMs(per 100,000 adults) of Portugal and ATMs(per 100,000 adults) of Slovak Republic?
Your response must be concise. 139.3. In the year 2012, what is the difference between the ATMs(per 100,000 adults) in High income: nonOECD and ATMs(per 100,000 adults) in Namibia?
Your answer should be compact. 10.57. In the year 2012, what is the difference between the ATMs(per 100,000 adults) of High income: nonOECD and ATMs(per 100,000 adults) of Portugal?
Make the answer very short. -127.26. In the year 2012, what is the difference between the ATMs(per 100,000 adults) in High income: nonOECD and ATMs(per 100,000 adults) in Slovak Republic?
Provide a succinct answer. 3.75. In the year 2012, what is the difference between the ATMs(per 100,000 adults) of Namibia and ATMs(per 100,000 adults) of Portugal?
Ensure brevity in your answer.  -137.83. In the year 2012, what is the difference between the ATMs(per 100,000 adults) of Namibia and ATMs(per 100,000 adults) of Slovak Republic?
Your answer should be very brief. -6.83. In the year 2012, what is the difference between the ATMs(per 100,000 adults) of Portugal and ATMs(per 100,000 adults) of Slovak Republic?
Your answer should be compact. 131. In the year 2013, what is the difference between the ATMs(per 100,000 adults) of High income: nonOECD and ATMs(per 100,000 adults) of Namibia?
Your response must be concise. 5.92. In the year 2013, what is the difference between the ATMs(per 100,000 adults) in High income: nonOECD and ATMs(per 100,000 adults) in Portugal?
Offer a terse response. -124.04. In the year 2013, what is the difference between the ATMs(per 100,000 adults) of High income: nonOECD and ATMs(per 100,000 adults) of Slovak Republic?
Your response must be concise. 0.96. In the year 2013, what is the difference between the ATMs(per 100,000 adults) in Namibia and ATMs(per 100,000 adults) in Portugal?
Ensure brevity in your answer.  -129.96. In the year 2013, what is the difference between the ATMs(per 100,000 adults) of Namibia and ATMs(per 100,000 adults) of Slovak Republic?
Give a very brief answer. -4.97. In the year 2013, what is the difference between the ATMs(per 100,000 adults) of Portugal and ATMs(per 100,000 adults) of Slovak Republic?
Provide a short and direct response. 125. What is the ratio of the ATMs(per 100,000 adults) of Namibia in 2007 to that in 2008?
Offer a very short reply. 0.33. What is the ratio of the ATMs(per 100,000 adults) in Portugal in 2007 to that in 2008?
Your answer should be compact. 0.95. What is the ratio of the ATMs(per 100,000 adults) in Slovak Republic in 2007 to that in 2008?
Give a very brief answer. 0.97. What is the ratio of the ATMs(per 100,000 adults) of High income: nonOECD in 2007 to that in 2009?
Your response must be concise. 0.9. What is the ratio of the ATMs(per 100,000 adults) of Namibia in 2007 to that in 2009?
Make the answer very short. 0.24. What is the ratio of the ATMs(per 100,000 adults) of Portugal in 2007 to that in 2009?
Give a very brief answer. 0.92. What is the ratio of the ATMs(per 100,000 adults) in Slovak Republic in 2007 to that in 2009?
Your answer should be very brief. 0.96. What is the ratio of the ATMs(per 100,000 adults) of High income: nonOECD in 2007 to that in 2010?
Your answer should be compact. 0.91. What is the ratio of the ATMs(per 100,000 adults) in Namibia in 2007 to that in 2010?
Give a very brief answer. 0.2. What is the ratio of the ATMs(per 100,000 adults) of Portugal in 2007 to that in 2010?
Make the answer very short. 0.91. What is the ratio of the ATMs(per 100,000 adults) in Slovak Republic in 2007 to that in 2010?
Give a very brief answer. 0.94. What is the ratio of the ATMs(per 100,000 adults) in High income: nonOECD in 2007 to that in 2011?
Your answer should be very brief. 0.9. What is the ratio of the ATMs(per 100,000 adults) in Namibia in 2007 to that in 2011?
Offer a very short reply. 0.2. What is the ratio of the ATMs(per 100,000 adults) of Portugal in 2007 to that in 2011?
Provide a succinct answer. 0.92. What is the ratio of the ATMs(per 100,000 adults) of Slovak Republic in 2007 to that in 2011?
Provide a succinct answer. 0.91. What is the ratio of the ATMs(per 100,000 adults) of High income: nonOECD in 2007 to that in 2012?
Your response must be concise. 0.82. What is the ratio of the ATMs(per 100,000 adults) of Namibia in 2007 to that in 2012?
Offer a very short reply. 0.2. What is the ratio of the ATMs(per 100,000 adults) in Portugal in 2007 to that in 2012?
Your answer should be compact. 0.95. What is the ratio of the ATMs(per 100,000 adults) in Slovak Republic in 2007 to that in 2012?
Give a very brief answer. 0.88. What is the ratio of the ATMs(per 100,000 adults) of High income: nonOECD in 2007 to that in 2013?
Offer a very short reply. 0.84. What is the ratio of the ATMs(per 100,000 adults) of Namibia in 2007 to that in 2013?
Offer a terse response. 0.19. What is the ratio of the ATMs(per 100,000 adults) of Portugal in 2007 to that in 2013?
Your answer should be very brief. 0.98. What is the ratio of the ATMs(per 100,000 adults) of Slovak Republic in 2007 to that in 2013?
Make the answer very short. 0.85. What is the ratio of the ATMs(per 100,000 adults) in High income: nonOECD in 2008 to that in 2009?
Provide a short and direct response. 0.95. What is the ratio of the ATMs(per 100,000 adults) of Namibia in 2008 to that in 2009?
Offer a very short reply. 0.71. What is the ratio of the ATMs(per 100,000 adults) of Portugal in 2008 to that in 2009?
Keep it short and to the point. 0.97. What is the ratio of the ATMs(per 100,000 adults) in Slovak Republic in 2008 to that in 2009?
Provide a short and direct response. 0.99. What is the ratio of the ATMs(per 100,000 adults) of High income: nonOECD in 2008 to that in 2010?
Give a very brief answer. 0.97. What is the ratio of the ATMs(per 100,000 adults) of Namibia in 2008 to that in 2010?
Your answer should be very brief. 0.6. What is the ratio of the ATMs(per 100,000 adults) of Portugal in 2008 to that in 2010?
Your answer should be very brief. 0.96. What is the ratio of the ATMs(per 100,000 adults) in Slovak Republic in 2008 to that in 2010?
Your answer should be very brief. 0.97. What is the ratio of the ATMs(per 100,000 adults) in High income: nonOECD in 2008 to that in 2011?
Offer a very short reply. 0.96. What is the ratio of the ATMs(per 100,000 adults) of Namibia in 2008 to that in 2011?
Your answer should be compact. 0.59. What is the ratio of the ATMs(per 100,000 adults) in Portugal in 2008 to that in 2011?
Provide a succinct answer. 0.98. What is the ratio of the ATMs(per 100,000 adults) in Slovak Republic in 2008 to that in 2011?
Your answer should be compact. 0.94. What is the ratio of the ATMs(per 100,000 adults) in High income: nonOECD in 2008 to that in 2012?
Your answer should be compact. 0.87. What is the ratio of the ATMs(per 100,000 adults) of Namibia in 2008 to that in 2012?
Make the answer very short. 0.61. What is the ratio of the ATMs(per 100,000 adults) in Portugal in 2008 to that in 2012?
Ensure brevity in your answer.  1.01. What is the ratio of the ATMs(per 100,000 adults) in Slovak Republic in 2008 to that in 2012?
Provide a succinct answer. 0.91. What is the ratio of the ATMs(per 100,000 adults) in High income: nonOECD in 2008 to that in 2013?
Provide a short and direct response. 0.89. What is the ratio of the ATMs(per 100,000 adults) of Namibia in 2008 to that in 2013?
Give a very brief answer. 0.57. What is the ratio of the ATMs(per 100,000 adults) in Portugal in 2008 to that in 2013?
Your answer should be compact. 1.03. What is the ratio of the ATMs(per 100,000 adults) of Slovak Republic in 2008 to that in 2013?
Your response must be concise. 0.88. What is the ratio of the ATMs(per 100,000 adults) in High income: nonOECD in 2009 to that in 2010?
Provide a short and direct response. 1.01. What is the ratio of the ATMs(per 100,000 adults) of Namibia in 2009 to that in 2010?
Offer a terse response. 0.85. What is the ratio of the ATMs(per 100,000 adults) in Portugal in 2009 to that in 2010?
Offer a terse response. 0.99. What is the ratio of the ATMs(per 100,000 adults) in Slovak Republic in 2009 to that in 2010?
Your answer should be compact. 0.98. What is the ratio of the ATMs(per 100,000 adults) in High income: nonOECD in 2009 to that in 2011?
Provide a succinct answer. 1.01. What is the ratio of the ATMs(per 100,000 adults) of Namibia in 2009 to that in 2011?
Your answer should be very brief. 0.83. What is the ratio of the ATMs(per 100,000 adults) in Slovak Republic in 2009 to that in 2011?
Make the answer very short. 0.95. What is the ratio of the ATMs(per 100,000 adults) of High income: nonOECD in 2009 to that in 2012?
Your response must be concise. 0.91. What is the ratio of the ATMs(per 100,000 adults) in Namibia in 2009 to that in 2012?
Your answer should be very brief. 0.86. What is the ratio of the ATMs(per 100,000 adults) of Portugal in 2009 to that in 2012?
Offer a very short reply. 1.04. What is the ratio of the ATMs(per 100,000 adults) in Slovak Republic in 2009 to that in 2012?
Give a very brief answer. 0.92. What is the ratio of the ATMs(per 100,000 adults) in High income: nonOECD in 2009 to that in 2013?
Give a very brief answer. 0.93. What is the ratio of the ATMs(per 100,000 adults) in Namibia in 2009 to that in 2013?
Give a very brief answer. 0.8. What is the ratio of the ATMs(per 100,000 adults) of Portugal in 2009 to that in 2013?
Your answer should be very brief. 1.06. What is the ratio of the ATMs(per 100,000 adults) of Slovak Republic in 2009 to that in 2013?
Your answer should be compact. 0.89. What is the ratio of the ATMs(per 100,000 adults) of High income: nonOECD in 2010 to that in 2011?
Keep it short and to the point. 0.99. What is the ratio of the ATMs(per 100,000 adults) of Namibia in 2010 to that in 2011?
Your response must be concise. 0.97. What is the ratio of the ATMs(per 100,000 adults) in Portugal in 2010 to that in 2011?
Ensure brevity in your answer.  1.02. What is the ratio of the ATMs(per 100,000 adults) of Slovak Republic in 2010 to that in 2011?
Your answer should be very brief. 0.97. What is the ratio of the ATMs(per 100,000 adults) of High income: nonOECD in 2010 to that in 2012?
Provide a short and direct response. 0.9. What is the ratio of the ATMs(per 100,000 adults) in Portugal in 2010 to that in 2012?
Offer a terse response. 1.05. What is the ratio of the ATMs(per 100,000 adults) of Slovak Republic in 2010 to that in 2012?
Ensure brevity in your answer.  0.94. What is the ratio of the ATMs(per 100,000 adults) in High income: nonOECD in 2010 to that in 2013?
Give a very brief answer. 0.92. What is the ratio of the ATMs(per 100,000 adults) of Namibia in 2010 to that in 2013?
Keep it short and to the point. 0.95. What is the ratio of the ATMs(per 100,000 adults) in Portugal in 2010 to that in 2013?
Provide a succinct answer. 1.08. What is the ratio of the ATMs(per 100,000 adults) in Slovak Republic in 2010 to that in 2013?
Offer a terse response. 0.91. What is the ratio of the ATMs(per 100,000 adults) of High income: nonOECD in 2011 to that in 2012?
Offer a terse response. 0.91. What is the ratio of the ATMs(per 100,000 adults) in Namibia in 2011 to that in 2012?
Ensure brevity in your answer.  1.04. What is the ratio of the ATMs(per 100,000 adults) in Portugal in 2011 to that in 2012?
Your answer should be very brief. 1.03. What is the ratio of the ATMs(per 100,000 adults) of Slovak Republic in 2011 to that in 2012?
Offer a very short reply. 0.96. What is the ratio of the ATMs(per 100,000 adults) in High income: nonOECD in 2011 to that in 2013?
Ensure brevity in your answer.  0.93. What is the ratio of the ATMs(per 100,000 adults) of Namibia in 2011 to that in 2013?
Your response must be concise. 0.97. What is the ratio of the ATMs(per 100,000 adults) of Portugal in 2011 to that in 2013?
Offer a terse response. 1.06. What is the ratio of the ATMs(per 100,000 adults) in Slovak Republic in 2011 to that in 2013?
Your answer should be very brief. 0.93. What is the ratio of the ATMs(per 100,000 adults) of High income: nonOECD in 2012 to that in 2013?
Keep it short and to the point. 1.02. What is the ratio of the ATMs(per 100,000 adults) in Namibia in 2012 to that in 2013?
Offer a very short reply. 0.93. What is the ratio of the ATMs(per 100,000 adults) of Portugal in 2012 to that in 2013?
Make the answer very short. 1.02. What is the ratio of the ATMs(per 100,000 adults) of Slovak Republic in 2012 to that in 2013?
Make the answer very short. 0.97. What is the difference between the highest and the second highest ATMs(per 100,000 adults) in High income: nonOECD?
Keep it short and to the point. 1.23. What is the difference between the highest and the second highest ATMs(per 100,000 adults) in Namibia?
Your response must be concise. 1.44. What is the difference between the highest and the second highest ATMs(per 100,000 adults) of Portugal?
Offer a very short reply. 2.86. What is the difference between the highest and the second highest ATMs(per 100,000 adults) of Slovak Republic?
Your answer should be very brief. 1.56. What is the difference between the highest and the lowest ATMs(per 100,000 adults) of High income: nonOECD?
Give a very brief answer. 10.57. What is the difference between the highest and the lowest ATMs(per 100,000 adults) in Namibia?
Your answer should be compact. 41.45. What is the difference between the highest and the lowest ATMs(per 100,000 adults) of Portugal?
Ensure brevity in your answer.  18.1. What is the difference between the highest and the lowest ATMs(per 100,000 adults) in Slovak Republic?
Your response must be concise. 8.21. 